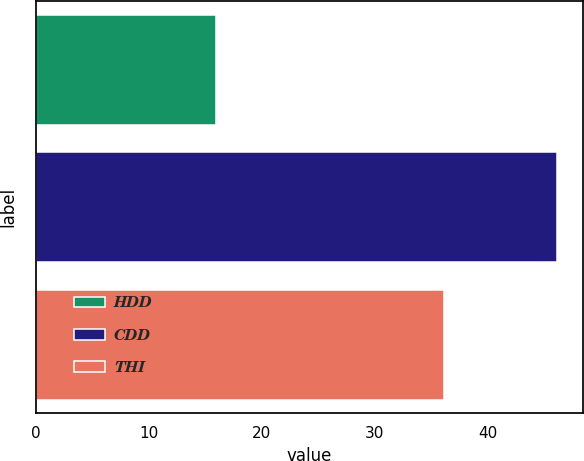Convert chart to OTSL. <chart><loc_0><loc_0><loc_500><loc_500><bar_chart><fcel>HDD<fcel>CDD<fcel>THI<nl><fcel>15.9<fcel>46.1<fcel>36.1<nl></chart> 